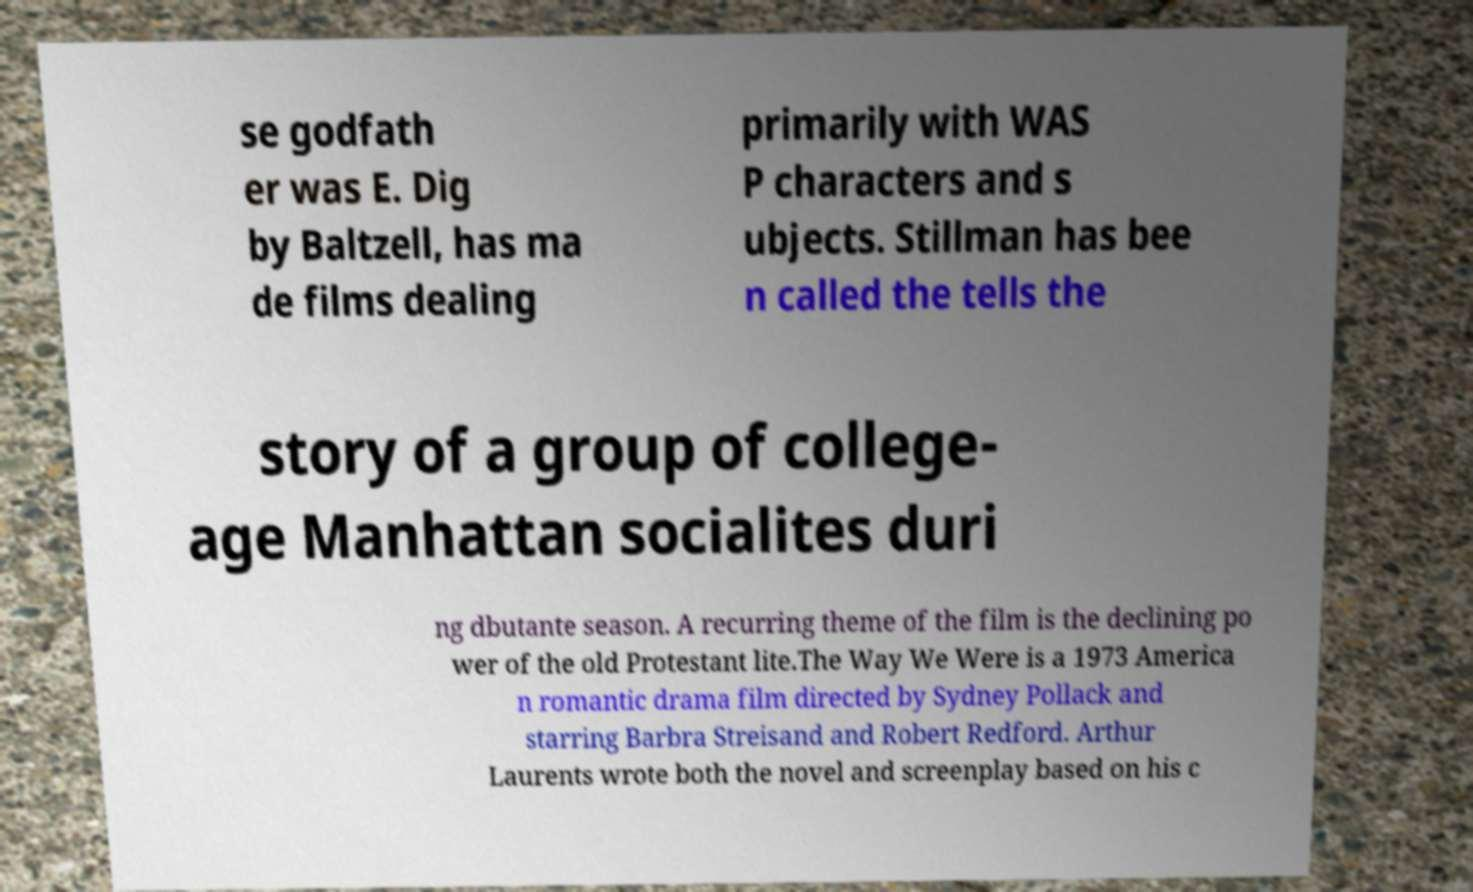I need the written content from this picture converted into text. Can you do that? se godfath er was E. Dig by Baltzell, has ma de films dealing primarily with WAS P characters and s ubjects. Stillman has bee n called the tells the story of a group of college- age Manhattan socialites duri ng dbutante season. A recurring theme of the film is the declining po wer of the old Protestant lite.The Way We Were is a 1973 America n romantic drama film directed by Sydney Pollack and starring Barbra Streisand and Robert Redford. Arthur Laurents wrote both the novel and screenplay based on his c 